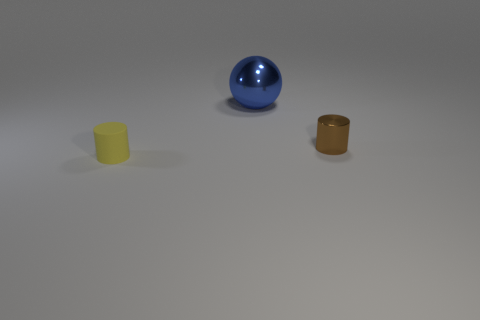Is the number of metallic cylinders on the left side of the small brown cylinder the same as the number of tiny brown objects behind the big blue sphere?
Make the answer very short. Yes. There is another matte object that is the same shape as the brown object; what size is it?
Make the answer very short. Small. What is the size of the thing that is in front of the big shiny ball and right of the small yellow cylinder?
Ensure brevity in your answer.  Small. Are there any shiny cylinders on the left side of the tiny yellow matte cylinder?
Provide a succinct answer. No. How many things are small cylinders in front of the tiny shiny cylinder or green matte objects?
Keep it short and to the point. 1. There is a thing on the left side of the blue object; what number of tiny metallic cylinders are in front of it?
Offer a terse response. 0. Are there fewer tiny yellow rubber objects that are to the left of the yellow cylinder than brown metal objects that are right of the tiny brown thing?
Give a very brief answer. No. There is a tiny object that is behind the cylinder on the left side of the small brown shiny object; what is its shape?
Ensure brevity in your answer.  Cylinder. How many other things are there of the same material as the tiny brown thing?
Provide a succinct answer. 1. Is there any other thing that is the same size as the brown object?
Your answer should be very brief. Yes. 